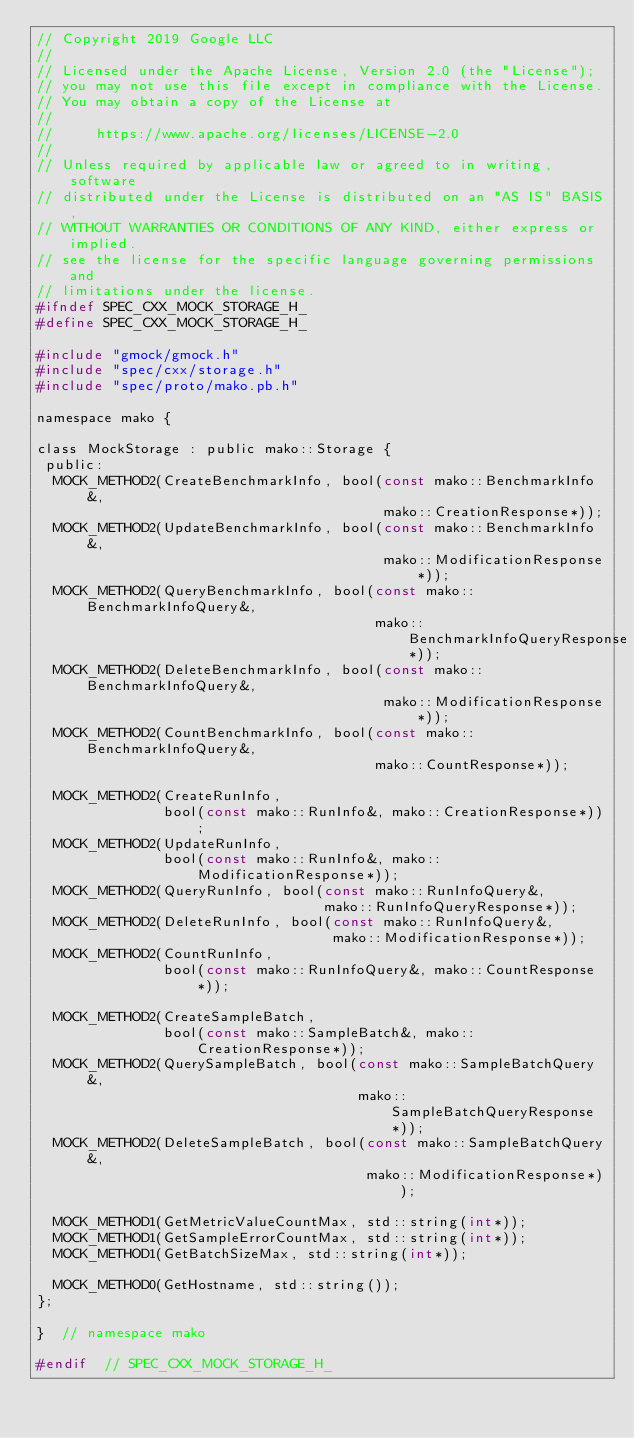<code> <loc_0><loc_0><loc_500><loc_500><_C_>// Copyright 2019 Google LLC
//
// Licensed under the Apache License, Version 2.0 (the "License");
// you may not use this file except in compliance with the License.
// You may obtain a copy of the License at
//
//     https://www.apache.org/licenses/LICENSE-2.0
//
// Unless required by applicable law or agreed to in writing, software
// distributed under the License is distributed on an "AS IS" BASIS,
// WITHOUT WARRANTIES OR CONDITIONS OF ANY KIND, either express or implied.
// see the license for the specific language governing permissions and
// limitations under the license.
#ifndef SPEC_CXX_MOCK_STORAGE_H_
#define SPEC_CXX_MOCK_STORAGE_H_

#include "gmock/gmock.h"
#include "spec/cxx/storage.h"
#include "spec/proto/mako.pb.h"

namespace mako {

class MockStorage : public mako::Storage {
 public:
  MOCK_METHOD2(CreateBenchmarkInfo, bool(const mako::BenchmarkInfo&,
                                         mako::CreationResponse*));
  MOCK_METHOD2(UpdateBenchmarkInfo, bool(const mako::BenchmarkInfo&,
                                         mako::ModificationResponse*));
  MOCK_METHOD2(QueryBenchmarkInfo, bool(const mako::BenchmarkInfoQuery&,
                                        mako::BenchmarkInfoQueryResponse*));
  MOCK_METHOD2(DeleteBenchmarkInfo, bool(const mako::BenchmarkInfoQuery&,
                                         mako::ModificationResponse*));
  MOCK_METHOD2(CountBenchmarkInfo, bool(const mako::BenchmarkInfoQuery&,
                                        mako::CountResponse*));

  MOCK_METHOD2(CreateRunInfo,
               bool(const mako::RunInfo&, mako::CreationResponse*));
  MOCK_METHOD2(UpdateRunInfo,
               bool(const mako::RunInfo&, mako::ModificationResponse*));
  MOCK_METHOD2(QueryRunInfo, bool(const mako::RunInfoQuery&,
                                  mako::RunInfoQueryResponse*));
  MOCK_METHOD2(DeleteRunInfo, bool(const mako::RunInfoQuery&,
                                   mako::ModificationResponse*));
  MOCK_METHOD2(CountRunInfo,
               bool(const mako::RunInfoQuery&, mako::CountResponse*));

  MOCK_METHOD2(CreateSampleBatch,
               bool(const mako::SampleBatch&, mako::CreationResponse*));
  MOCK_METHOD2(QuerySampleBatch, bool(const mako::SampleBatchQuery&,
                                      mako::SampleBatchQueryResponse*));
  MOCK_METHOD2(DeleteSampleBatch, bool(const mako::SampleBatchQuery&,
                                       mako::ModificationResponse*));

  MOCK_METHOD1(GetMetricValueCountMax, std::string(int*));
  MOCK_METHOD1(GetSampleErrorCountMax, std::string(int*));
  MOCK_METHOD1(GetBatchSizeMax, std::string(int*));

  MOCK_METHOD0(GetHostname, std::string());
};

}  // namespace mako

#endif  // SPEC_CXX_MOCK_STORAGE_H_
</code> 